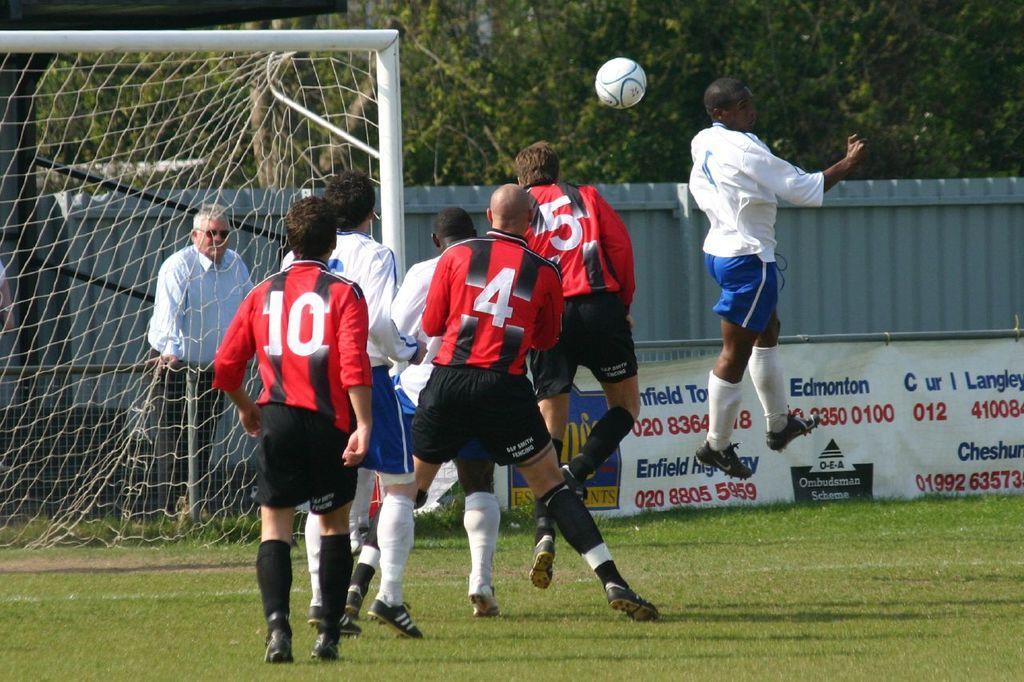How would you summarize this image in a sentence or two? In this picture I can see there are few people playing and there is grass on the floor, among them few are wearing red and black jersey and the rest are wearing a white jersey and a blue trouser. There is a net at left side, a person standing behind the fence and there are few trees in the backdrop, there is a banner at right bottom of the image. 